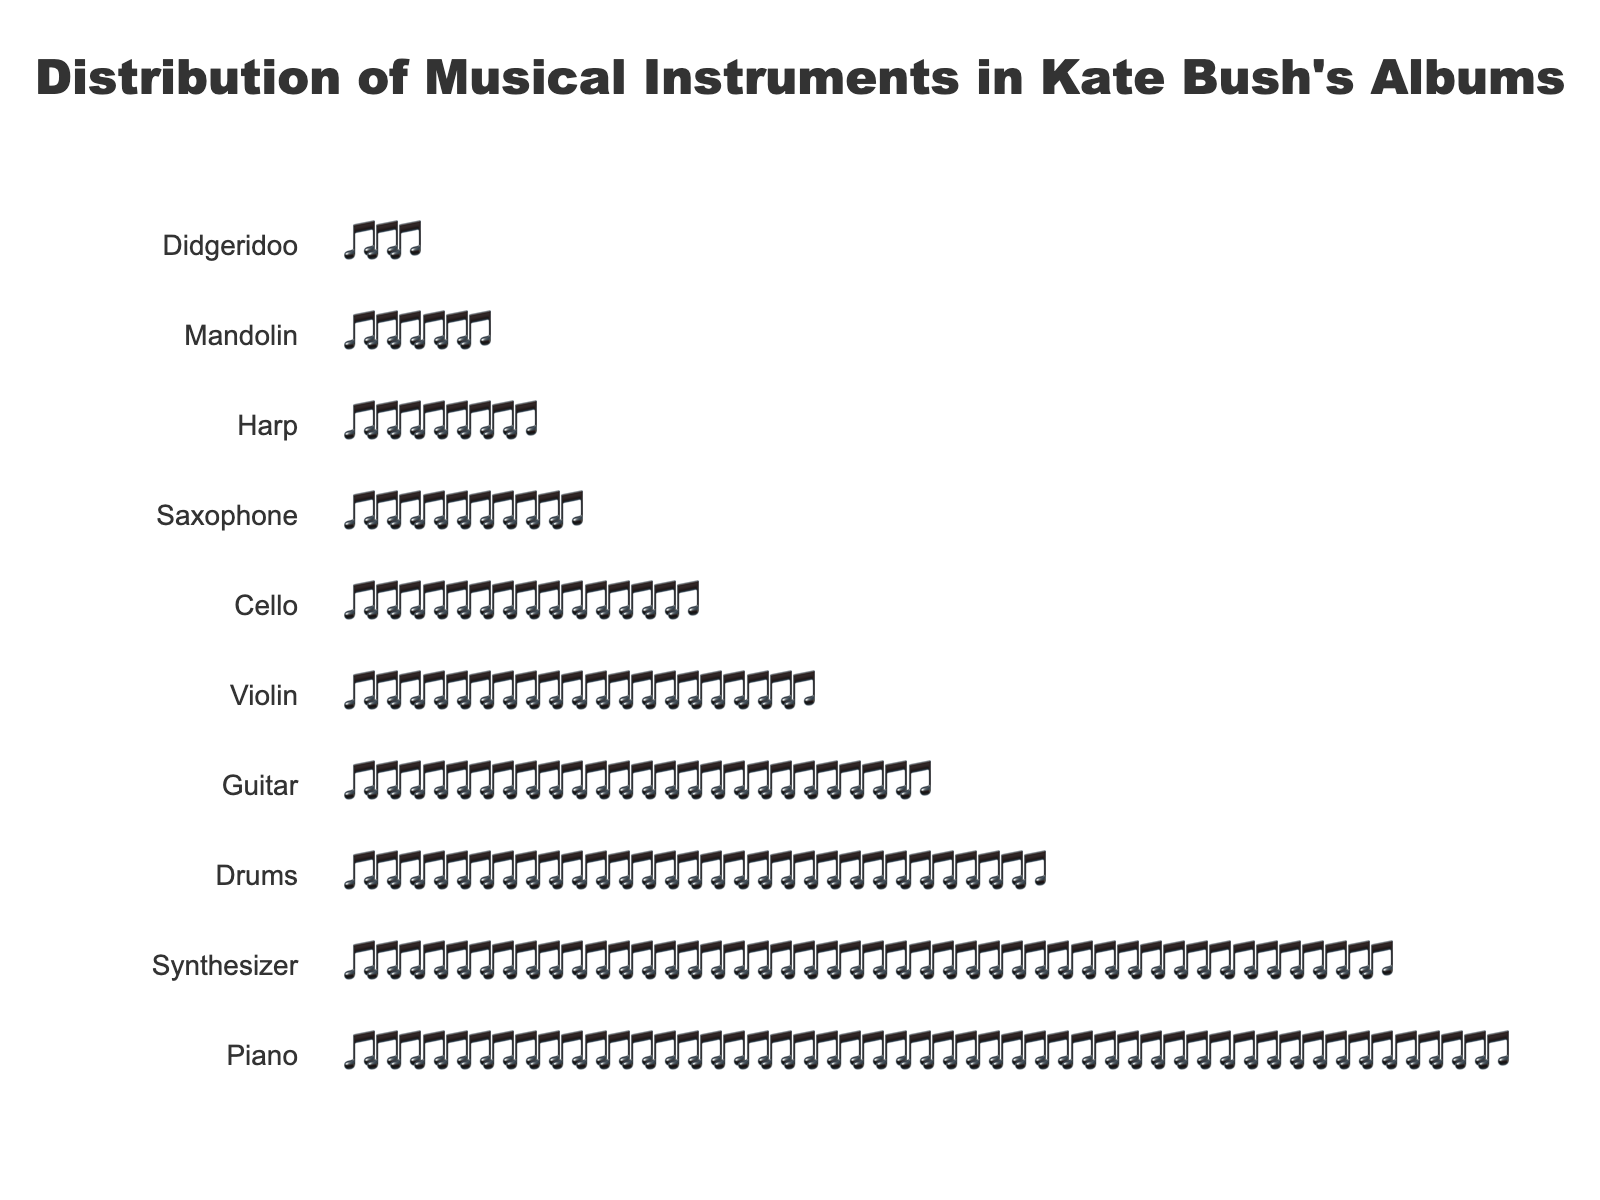What is the title of the figure? The title is usually found at the top of the figure and is meant to summarize the content of the plot. In this case, the title states what data is being represented.
Answer: Distribution of Musical Instruments in Kate Bush's Albums Which instrument appears most frequently? The most frequently appearing instrument will have the most music note emojis aligned with it. By looking at the plot, determine which instrument has the longest row of notes.
Answer: Piano How many different types of instruments are used? Each different row in the plot represents a different type of instrument. By counting the rows, you can determine how many different instruments are used.
Answer: 10 Out of the top three most used instruments, which one is used the least? First, identify the top three instruments with the most notes. Then, compare their frequencies and determine which one has the smallest count.
Answer: Drums What is the difference in the number of times Piano and Guitar are used? Count the notes for Piano and Guitar respectively. Subtract the number of Guitar notes from the number of Piano notes.
Answer: 25 Which instrument is used more frequently: Violin or Cello? Compare the rows associated with Violin and Cello. The row with more notes indicates the more frequently used instrument.
Answer: Violin How many instruments are used less than 10 times? Look for the rows that have fewer than 10 notes. Count the number of such rows to find the answer.
Answer: 3 What is the combined total of notes for Harp and Mandolin? Count the number of notes for Harp and Mandolin separately. Add these two counts together to get the combined total.
Answer: 14 If you add the counts of the top five instruments, what is the total? Identify the top five instruments with the most notes. Add their note counts together to get the total.
Answer: 170 What proportion of the total does the Synthesizer represent? First, find the total sum of all notes. Then, divide the Synthesizer count by this total and multiply by 100 to get the percentage.
Answer: 18.75% 